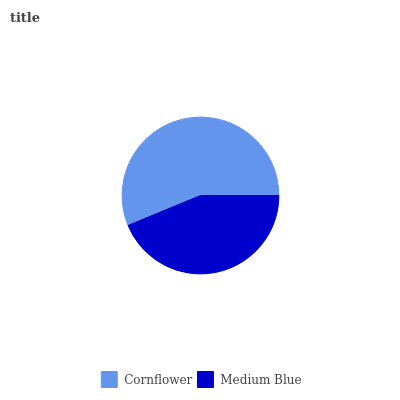Is Medium Blue the minimum?
Answer yes or no. Yes. Is Cornflower the maximum?
Answer yes or no. Yes. Is Medium Blue the maximum?
Answer yes or no. No. Is Cornflower greater than Medium Blue?
Answer yes or no. Yes. Is Medium Blue less than Cornflower?
Answer yes or no. Yes. Is Medium Blue greater than Cornflower?
Answer yes or no. No. Is Cornflower less than Medium Blue?
Answer yes or no. No. Is Cornflower the high median?
Answer yes or no. Yes. Is Medium Blue the low median?
Answer yes or no. Yes. Is Medium Blue the high median?
Answer yes or no. No. Is Cornflower the low median?
Answer yes or no. No. 